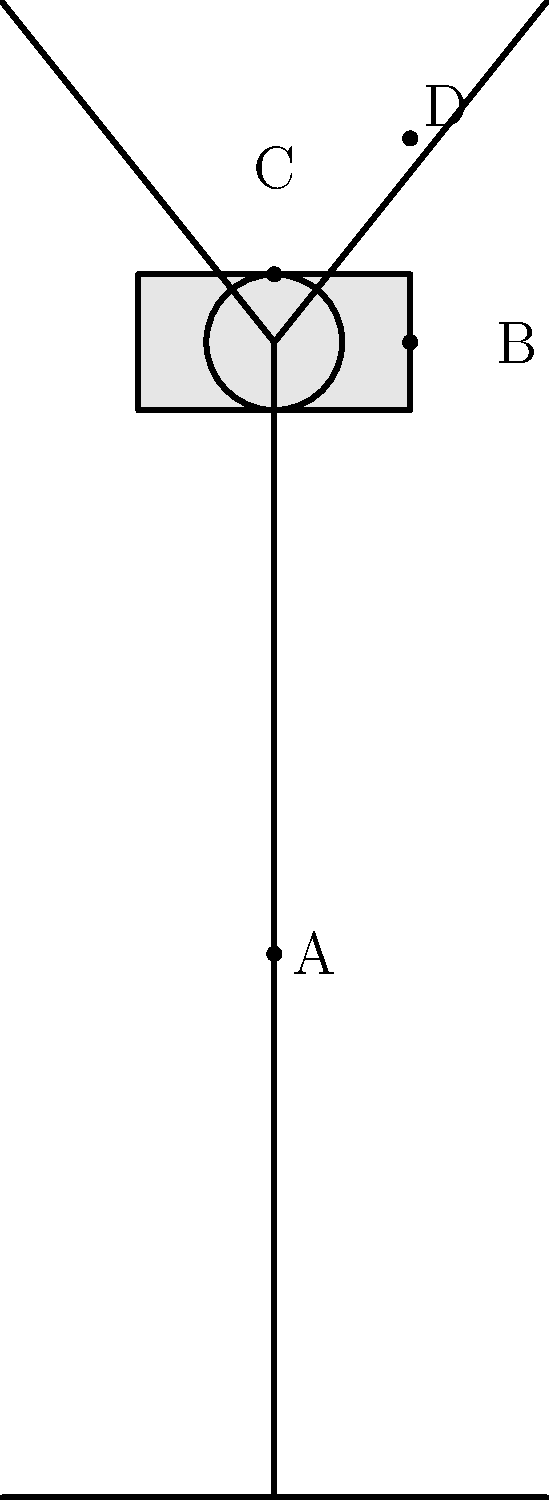Label the parts of this wind turbine schematic. What components are represented by points A, B, C, and D? To identify the parts of a wind turbine, let's analyze the schematic diagram step-by-step:

1. Point A is located on the vertical structure that supports the entire turbine. This is called the tower, which provides height to capture stronger winds.

2. Point B is on the box-like structure at the top of the tower. This is the nacelle, which houses the generator, gearbox, and other mechanical components.

3. Point C is at the center where the blades meet. This is the hub, which connects the blades to the nacelle and transfers the rotational energy to the generator.

4. Point D is on one of the long, curved structures extending from the hub. These are the blades (or rotor blades) that capture wind energy and convert it into rotational motion.

Understanding these components is crucial for environmental science education, as wind turbines are an important renewable energy technology. In Nepal, where hydropower is dominant, diversifying with wind energy could be beneficial for sustainable development.
Answer: A: Tower, B: Nacelle, C: Hub, D: Blade 